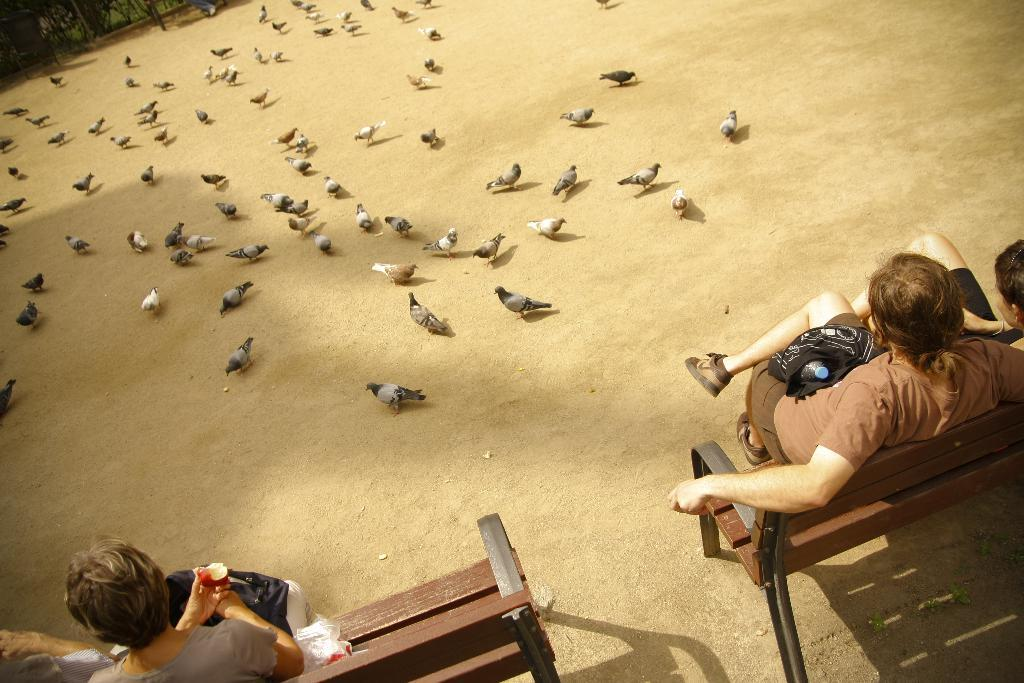What are the people in the image doing? The people in the image are sitting on benches. What else can be seen on the ground in the image? There are birds on the ground in the image. What is visible in the background of the image? There appear to be trees in the background of the image. What type of dinosaurs can be seen roaming around in the image? There are no dinosaurs present in the image; it features people sitting on benches and birds on the ground. What is the shocking event that occurs in the image? There is no shocking event depicted in the image; it is a peaceful scene with people sitting on benches and birds on the ground. 